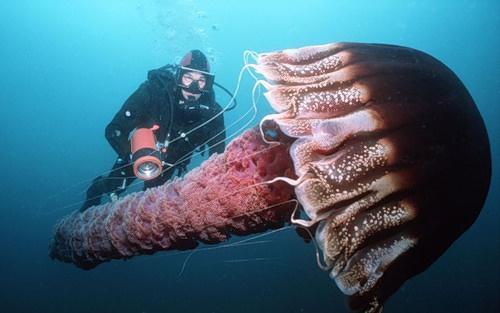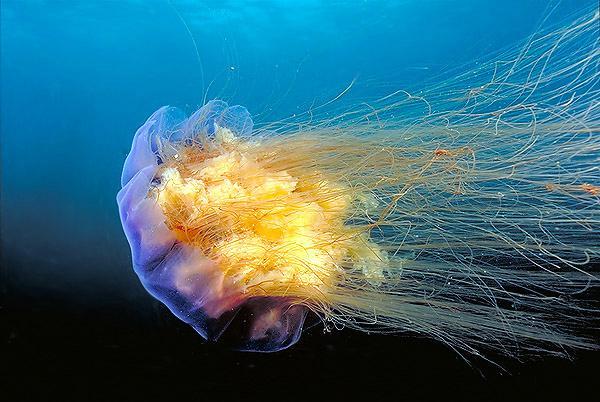The first image is the image on the left, the second image is the image on the right. For the images shown, is this caption "The left image contains one human scuba diving." true? Answer yes or no. Yes. The first image is the image on the left, the second image is the image on the right. Considering the images on both sides, is "One scuba diver is to the right of a jelly fish." valid? Answer yes or no. No. 